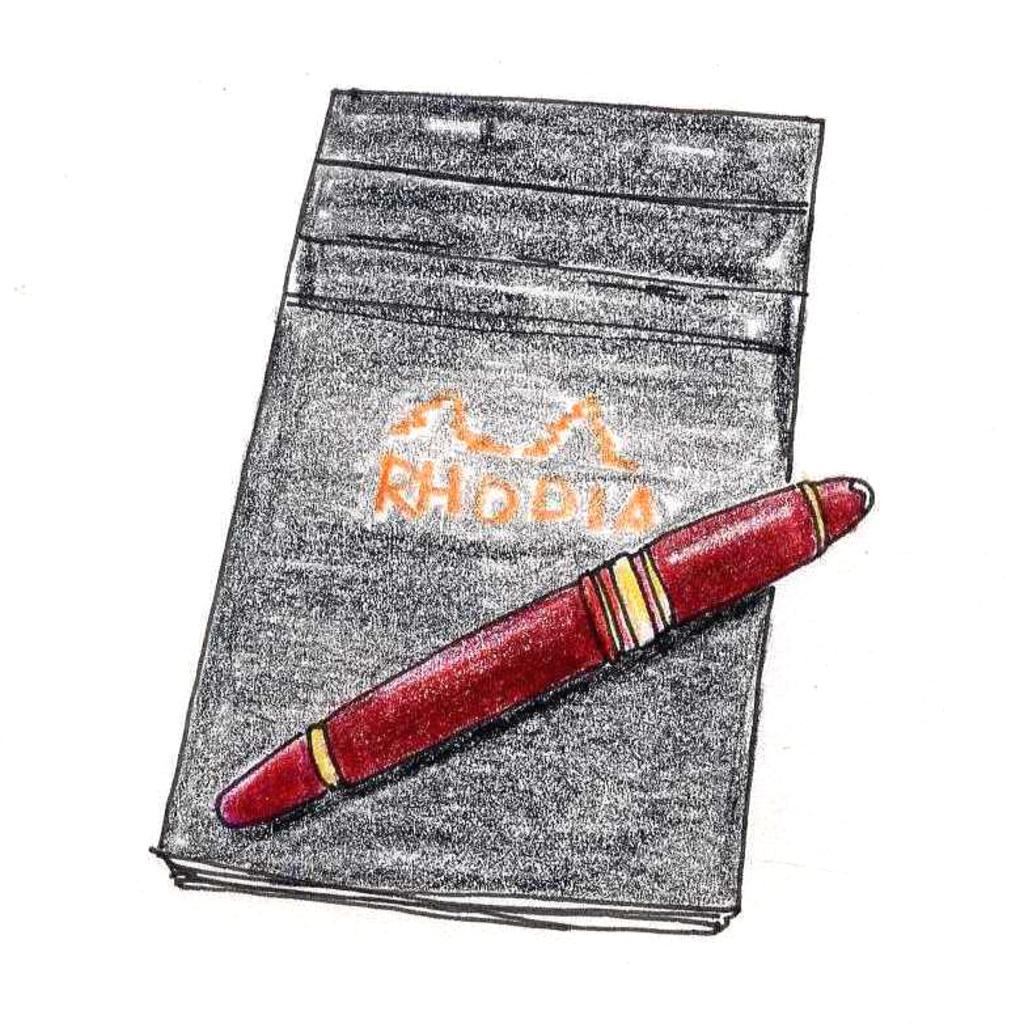What type of artwork is depicted in the image? The image is a painting. What object can be seen in the painting? There is a book in the painting. What is written on the book? There is text written on the book. What is placed on top of the book? There is a pen on the book. How many legs can be seen on the book in the image? There are no legs visible on the book in the image, as books do not have legs. 